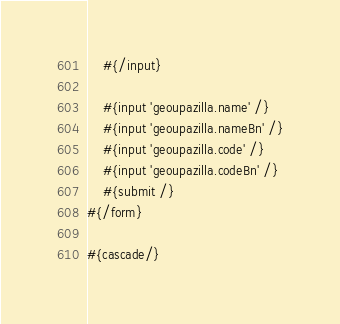Convert code to text. <code><loc_0><loc_0><loc_500><loc_500><_HTML_>	#{/input} 	

	#{input 'geoupazilla.name' /}
    #{input 'geoupazilla.nameBn' /}
	#{input 'geoupazilla.code' /}
	#{input 'geoupazilla.codeBn' /}
    #{submit /}
#{/form}

#{cascade/}</code> 